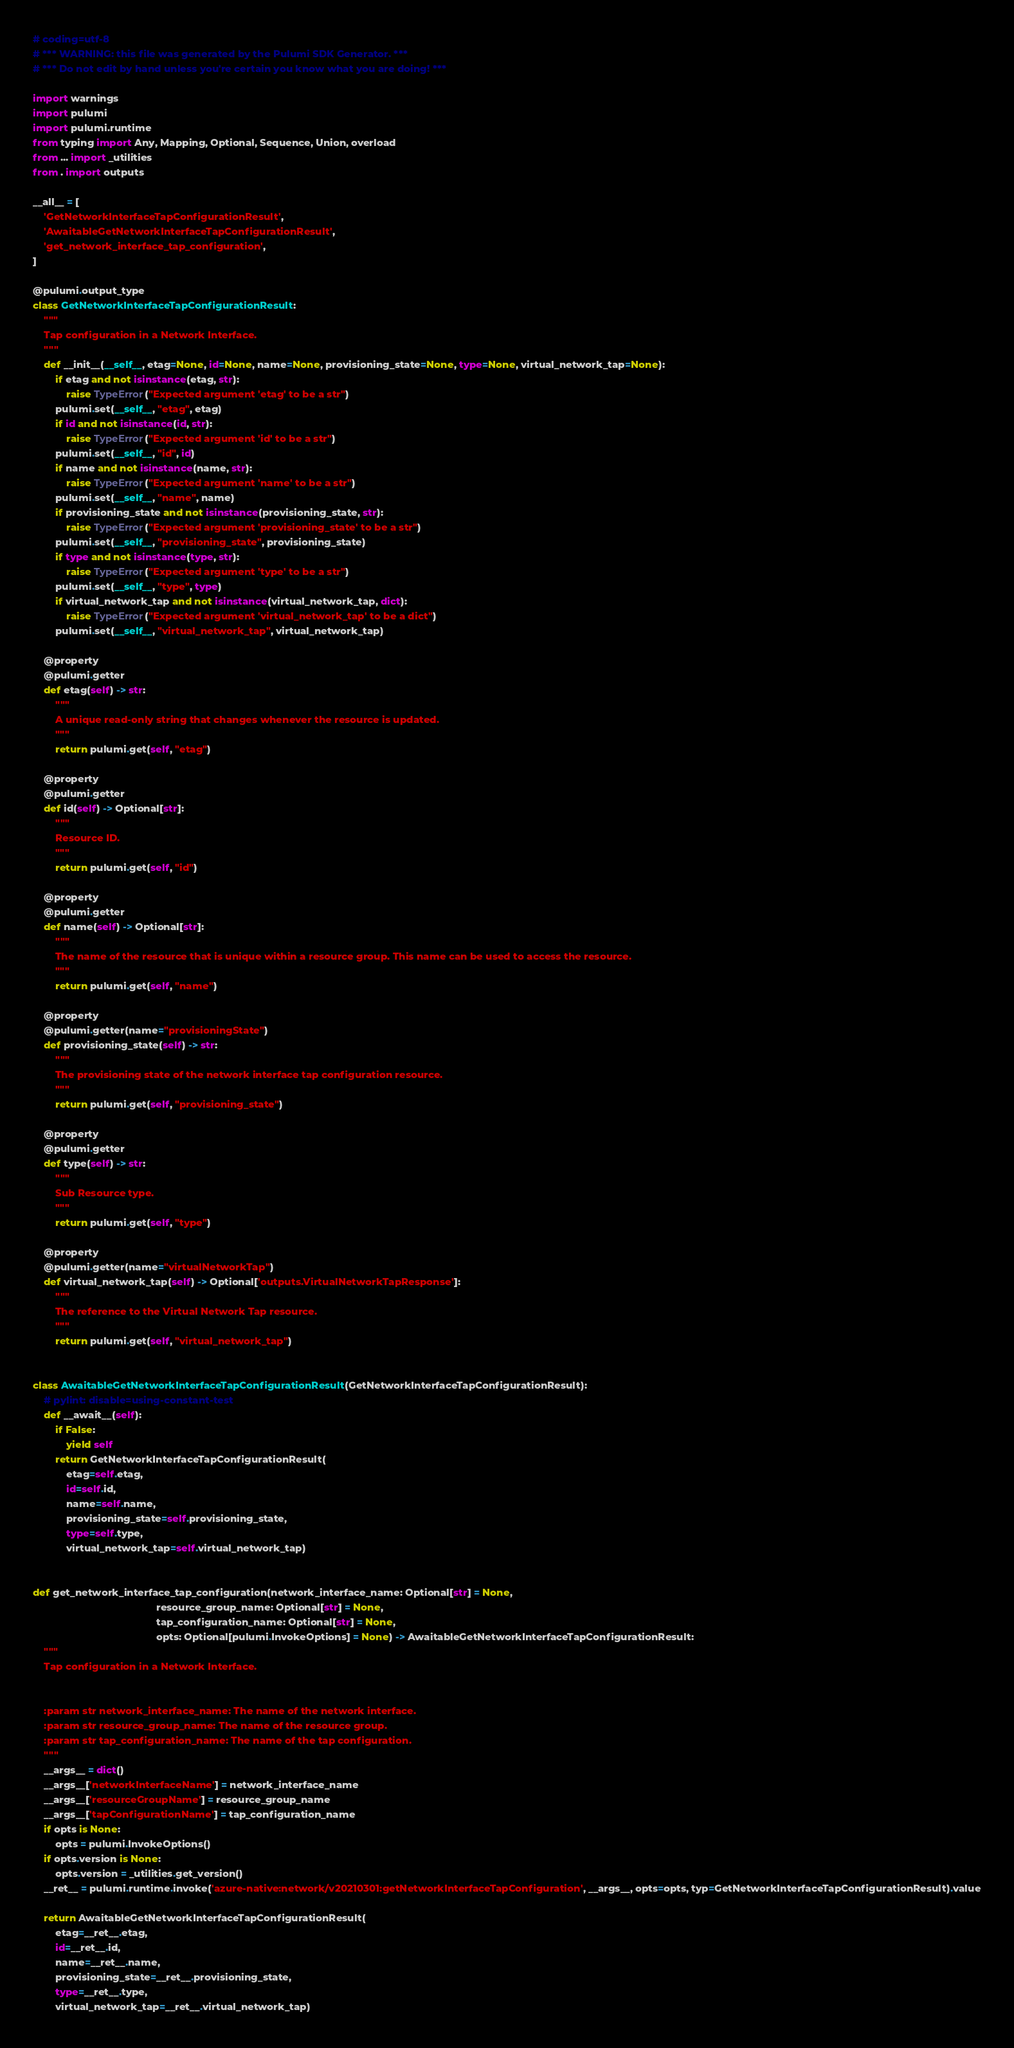Convert code to text. <code><loc_0><loc_0><loc_500><loc_500><_Python_># coding=utf-8
# *** WARNING: this file was generated by the Pulumi SDK Generator. ***
# *** Do not edit by hand unless you're certain you know what you are doing! ***

import warnings
import pulumi
import pulumi.runtime
from typing import Any, Mapping, Optional, Sequence, Union, overload
from ... import _utilities
from . import outputs

__all__ = [
    'GetNetworkInterfaceTapConfigurationResult',
    'AwaitableGetNetworkInterfaceTapConfigurationResult',
    'get_network_interface_tap_configuration',
]

@pulumi.output_type
class GetNetworkInterfaceTapConfigurationResult:
    """
    Tap configuration in a Network Interface.
    """
    def __init__(__self__, etag=None, id=None, name=None, provisioning_state=None, type=None, virtual_network_tap=None):
        if etag and not isinstance(etag, str):
            raise TypeError("Expected argument 'etag' to be a str")
        pulumi.set(__self__, "etag", etag)
        if id and not isinstance(id, str):
            raise TypeError("Expected argument 'id' to be a str")
        pulumi.set(__self__, "id", id)
        if name and not isinstance(name, str):
            raise TypeError("Expected argument 'name' to be a str")
        pulumi.set(__self__, "name", name)
        if provisioning_state and not isinstance(provisioning_state, str):
            raise TypeError("Expected argument 'provisioning_state' to be a str")
        pulumi.set(__self__, "provisioning_state", provisioning_state)
        if type and not isinstance(type, str):
            raise TypeError("Expected argument 'type' to be a str")
        pulumi.set(__self__, "type", type)
        if virtual_network_tap and not isinstance(virtual_network_tap, dict):
            raise TypeError("Expected argument 'virtual_network_tap' to be a dict")
        pulumi.set(__self__, "virtual_network_tap", virtual_network_tap)

    @property
    @pulumi.getter
    def etag(self) -> str:
        """
        A unique read-only string that changes whenever the resource is updated.
        """
        return pulumi.get(self, "etag")

    @property
    @pulumi.getter
    def id(self) -> Optional[str]:
        """
        Resource ID.
        """
        return pulumi.get(self, "id")

    @property
    @pulumi.getter
    def name(self) -> Optional[str]:
        """
        The name of the resource that is unique within a resource group. This name can be used to access the resource.
        """
        return pulumi.get(self, "name")

    @property
    @pulumi.getter(name="provisioningState")
    def provisioning_state(self) -> str:
        """
        The provisioning state of the network interface tap configuration resource.
        """
        return pulumi.get(self, "provisioning_state")

    @property
    @pulumi.getter
    def type(self) -> str:
        """
        Sub Resource type.
        """
        return pulumi.get(self, "type")

    @property
    @pulumi.getter(name="virtualNetworkTap")
    def virtual_network_tap(self) -> Optional['outputs.VirtualNetworkTapResponse']:
        """
        The reference to the Virtual Network Tap resource.
        """
        return pulumi.get(self, "virtual_network_tap")


class AwaitableGetNetworkInterfaceTapConfigurationResult(GetNetworkInterfaceTapConfigurationResult):
    # pylint: disable=using-constant-test
    def __await__(self):
        if False:
            yield self
        return GetNetworkInterfaceTapConfigurationResult(
            etag=self.etag,
            id=self.id,
            name=self.name,
            provisioning_state=self.provisioning_state,
            type=self.type,
            virtual_network_tap=self.virtual_network_tap)


def get_network_interface_tap_configuration(network_interface_name: Optional[str] = None,
                                            resource_group_name: Optional[str] = None,
                                            tap_configuration_name: Optional[str] = None,
                                            opts: Optional[pulumi.InvokeOptions] = None) -> AwaitableGetNetworkInterfaceTapConfigurationResult:
    """
    Tap configuration in a Network Interface.


    :param str network_interface_name: The name of the network interface.
    :param str resource_group_name: The name of the resource group.
    :param str tap_configuration_name: The name of the tap configuration.
    """
    __args__ = dict()
    __args__['networkInterfaceName'] = network_interface_name
    __args__['resourceGroupName'] = resource_group_name
    __args__['tapConfigurationName'] = tap_configuration_name
    if opts is None:
        opts = pulumi.InvokeOptions()
    if opts.version is None:
        opts.version = _utilities.get_version()
    __ret__ = pulumi.runtime.invoke('azure-native:network/v20210301:getNetworkInterfaceTapConfiguration', __args__, opts=opts, typ=GetNetworkInterfaceTapConfigurationResult).value

    return AwaitableGetNetworkInterfaceTapConfigurationResult(
        etag=__ret__.etag,
        id=__ret__.id,
        name=__ret__.name,
        provisioning_state=__ret__.provisioning_state,
        type=__ret__.type,
        virtual_network_tap=__ret__.virtual_network_tap)
</code> 